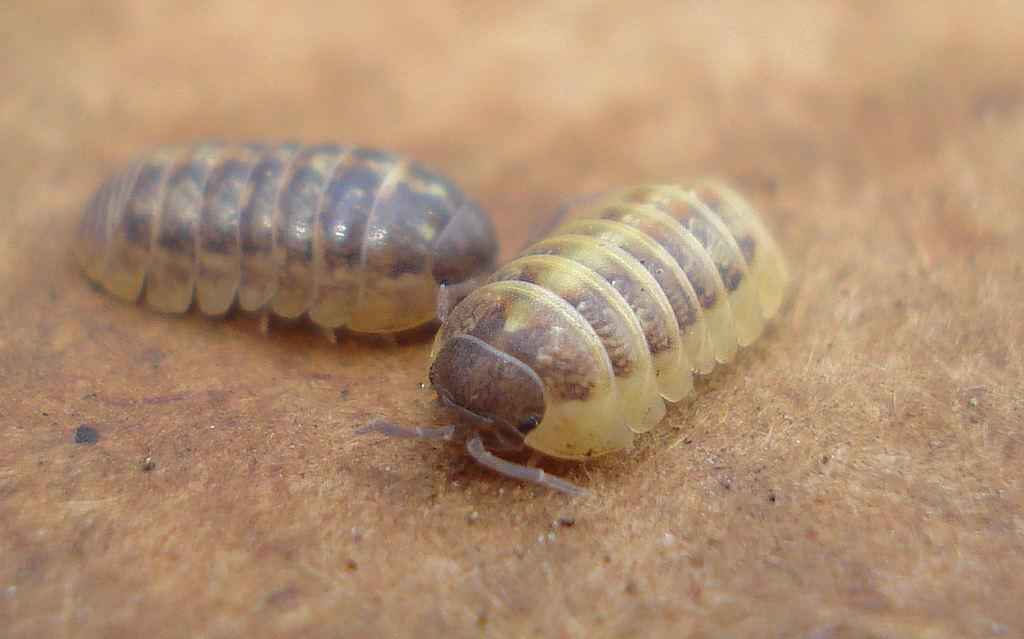What type of living organisms can be seen in the image? Insects can be seen in the image. What type of crate is being carried by the insects in the image? There is no crate present in the image, as it only features insects. 